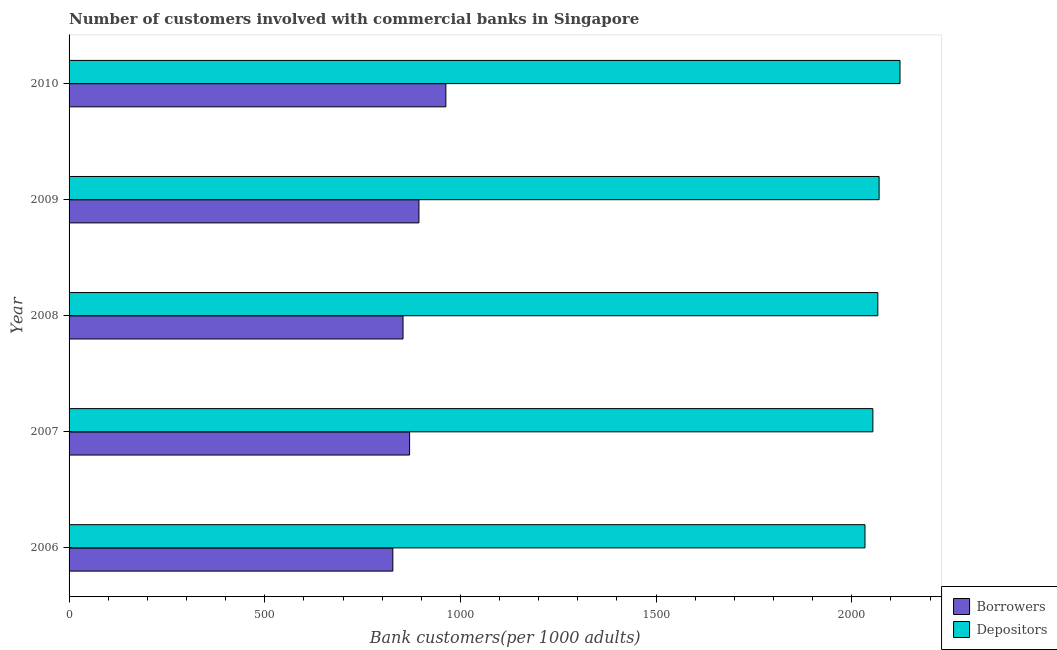How many different coloured bars are there?
Ensure brevity in your answer.  2. How many bars are there on the 3rd tick from the top?
Give a very brief answer. 2. What is the number of depositors in 2007?
Provide a succinct answer. 2053.95. Across all years, what is the maximum number of depositors?
Your answer should be compact. 2123.28. Across all years, what is the minimum number of depositors?
Provide a succinct answer. 2033.78. What is the total number of borrowers in the graph?
Ensure brevity in your answer.  4407.61. What is the difference between the number of borrowers in 2006 and that in 2010?
Offer a very short reply. -135.48. What is the difference between the number of borrowers in 2009 and the number of depositors in 2008?
Ensure brevity in your answer.  -1172.56. What is the average number of depositors per year?
Give a very brief answer. 2069.49. In the year 2007, what is the difference between the number of depositors and number of borrowers?
Give a very brief answer. 1183.82. What is the ratio of the number of depositors in 2007 to that in 2009?
Make the answer very short. 0.99. Is the number of depositors in 2008 less than that in 2010?
Ensure brevity in your answer.  Yes. Is the difference between the number of borrowers in 2008 and 2010 greater than the difference between the number of depositors in 2008 and 2010?
Provide a succinct answer. No. What is the difference between the highest and the second highest number of depositors?
Provide a succinct answer. 53.4. What is the difference between the highest and the lowest number of depositors?
Ensure brevity in your answer.  89.5. In how many years, is the number of depositors greater than the average number of depositors taken over all years?
Your answer should be very brief. 2. What does the 1st bar from the top in 2010 represents?
Provide a succinct answer. Depositors. What does the 1st bar from the bottom in 2009 represents?
Keep it short and to the point. Borrowers. How many bars are there?
Your answer should be compact. 10. Are all the bars in the graph horizontal?
Offer a terse response. Yes. How many years are there in the graph?
Provide a succinct answer. 5. Does the graph contain any zero values?
Ensure brevity in your answer.  No. Does the graph contain grids?
Offer a very short reply. No. How many legend labels are there?
Offer a terse response. 2. How are the legend labels stacked?
Your response must be concise. Vertical. What is the title of the graph?
Your response must be concise. Number of customers involved with commercial banks in Singapore. Does "Foreign Liabilities" appear as one of the legend labels in the graph?
Your answer should be compact. No. What is the label or title of the X-axis?
Your answer should be very brief. Bank customers(per 1000 adults). What is the Bank customers(per 1000 adults) in Borrowers in 2006?
Your answer should be compact. 827.32. What is the Bank customers(per 1000 adults) of Depositors in 2006?
Provide a succinct answer. 2033.78. What is the Bank customers(per 1000 adults) of Borrowers in 2007?
Make the answer very short. 870.13. What is the Bank customers(per 1000 adults) in Depositors in 2007?
Provide a short and direct response. 2053.95. What is the Bank customers(per 1000 adults) of Borrowers in 2008?
Your answer should be very brief. 853.36. What is the Bank customers(per 1000 adults) of Depositors in 2008?
Ensure brevity in your answer.  2066.57. What is the Bank customers(per 1000 adults) of Borrowers in 2009?
Your response must be concise. 894.01. What is the Bank customers(per 1000 adults) of Depositors in 2009?
Your answer should be very brief. 2069.88. What is the Bank customers(per 1000 adults) in Borrowers in 2010?
Ensure brevity in your answer.  962.8. What is the Bank customers(per 1000 adults) in Depositors in 2010?
Ensure brevity in your answer.  2123.28. Across all years, what is the maximum Bank customers(per 1000 adults) of Borrowers?
Your response must be concise. 962.8. Across all years, what is the maximum Bank customers(per 1000 adults) of Depositors?
Ensure brevity in your answer.  2123.28. Across all years, what is the minimum Bank customers(per 1000 adults) of Borrowers?
Offer a terse response. 827.32. Across all years, what is the minimum Bank customers(per 1000 adults) of Depositors?
Your response must be concise. 2033.78. What is the total Bank customers(per 1000 adults) of Borrowers in the graph?
Ensure brevity in your answer.  4407.61. What is the total Bank customers(per 1000 adults) in Depositors in the graph?
Make the answer very short. 1.03e+04. What is the difference between the Bank customers(per 1000 adults) of Borrowers in 2006 and that in 2007?
Provide a short and direct response. -42.81. What is the difference between the Bank customers(per 1000 adults) of Depositors in 2006 and that in 2007?
Offer a very short reply. -20.17. What is the difference between the Bank customers(per 1000 adults) in Borrowers in 2006 and that in 2008?
Keep it short and to the point. -26.04. What is the difference between the Bank customers(per 1000 adults) in Depositors in 2006 and that in 2008?
Provide a succinct answer. -32.79. What is the difference between the Bank customers(per 1000 adults) in Borrowers in 2006 and that in 2009?
Keep it short and to the point. -66.7. What is the difference between the Bank customers(per 1000 adults) in Depositors in 2006 and that in 2009?
Your answer should be very brief. -36.1. What is the difference between the Bank customers(per 1000 adults) of Borrowers in 2006 and that in 2010?
Keep it short and to the point. -135.48. What is the difference between the Bank customers(per 1000 adults) of Depositors in 2006 and that in 2010?
Your response must be concise. -89.5. What is the difference between the Bank customers(per 1000 adults) in Borrowers in 2007 and that in 2008?
Your response must be concise. 16.77. What is the difference between the Bank customers(per 1000 adults) in Depositors in 2007 and that in 2008?
Your answer should be very brief. -12.63. What is the difference between the Bank customers(per 1000 adults) of Borrowers in 2007 and that in 2009?
Make the answer very short. -23.89. What is the difference between the Bank customers(per 1000 adults) in Depositors in 2007 and that in 2009?
Offer a terse response. -15.93. What is the difference between the Bank customers(per 1000 adults) of Borrowers in 2007 and that in 2010?
Your answer should be very brief. -92.67. What is the difference between the Bank customers(per 1000 adults) in Depositors in 2007 and that in 2010?
Offer a very short reply. -69.33. What is the difference between the Bank customers(per 1000 adults) in Borrowers in 2008 and that in 2009?
Provide a succinct answer. -40.65. What is the difference between the Bank customers(per 1000 adults) of Depositors in 2008 and that in 2009?
Offer a very short reply. -3.3. What is the difference between the Bank customers(per 1000 adults) in Borrowers in 2008 and that in 2010?
Provide a short and direct response. -109.44. What is the difference between the Bank customers(per 1000 adults) in Depositors in 2008 and that in 2010?
Your answer should be very brief. -56.7. What is the difference between the Bank customers(per 1000 adults) in Borrowers in 2009 and that in 2010?
Your answer should be very brief. -68.78. What is the difference between the Bank customers(per 1000 adults) of Depositors in 2009 and that in 2010?
Give a very brief answer. -53.4. What is the difference between the Bank customers(per 1000 adults) of Borrowers in 2006 and the Bank customers(per 1000 adults) of Depositors in 2007?
Keep it short and to the point. -1226.63. What is the difference between the Bank customers(per 1000 adults) in Borrowers in 2006 and the Bank customers(per 1000 adults) in Depositors in 2008?
Your response must be concise. -1239.26. What is the difference between the Bank customers(per 1000 adults) in Borrowers in 2006 and the Bank customers(per 1000 adults) in Depositors in 2009?
Make the answer very short. -1242.56. What is the difference between the Bank customers(per 1000 adults) of Borrowers in 2006 and the Bank customers(per 1000 adults) of Depositors in 2010?
Provide a short and direct response. -1295.96. What is the difference between the Bank customers(per 1000 adults) of Borrowers in 2007 and the Bank customers(per 1000 adults) of Depositors in 2008?
Offer a terse response. -1196.45. What is the difference between the Bank customers(per 1000 adults) in Borrowers in 2007 and the Bank customers(per 1000 adults) in Depositors in 2009?
Your answer should be compact. -1199.75. What is the difference between the Bank customers(per 1000 adults) of Borrowers in 2007 and the Bank customers(per 1000 adults) of Depositors in 2010?
Your answer should be compact. -1253.15. What is the difference between the Bank customers(per 1000 adults) of Borrowers in 2008 and the Bank customers(per 1000 adults) of Depositors in 2009?
Your answer should be very brief. -1216.52. What is the difference between the Bank customers(per 1000 adults) of Borrowers in 2008 and the Bank customers(per 1000 adults) of Depositors in 2010?
Provide a succinct answer. -1269.92. What is the difference between the Bank customers(per 1000 adults) in Borrowers in 2009 and the Bank customers(per 1000 adults) in Depositors in 2010?
Keep it short and to the point. -1229.27. What is the average Bank customers(per 1000 adults) of Borrowers per year?
Keep it short and to the point. 881.52. What is the average Bank customers(per 1000 adults) in Depositors per year?
Offer a terse response. 2069.49. In the year 2006, what is the difference between the Bank customers(per 1000 adults) in Borrowers and Bank customers(per 1000 adults) in Depositors?
Provide a short and direct response. -1206.46. In the year 2007, what is the difference between the Bank customers(per 1000 adults) of Borrowers and Bank customers(per 1000 adults) of Depositors?
Your response must be concise. -1183.82. In the year 2008, what is the difference between the Bank customers(per 1000 adults) in Borrowers and Bank customers(per 1000 adults) in Depositors?
Keep it short and to the point. -1213.21. In the year 2009, what is the difference between the Bank customers(per 1000 adults) in Borrowers and Bank customers(per 1000 adults) in Depositors?
Keep it short and to the point. -1175.87. In the year 2010, what is the difference between the Bank customers(per 1000 adults) of Borrowers and Bank customers(per 1000 adults) of Depositors?
Your answer should be compact. -1160.48. What is the ratio of the Bank customers(per 1000 adults) in Borrowers in 2006 to that in 2007?
Your answer should be very brief. 0.95. What is the ratio of the Bank customers(per 1000 adults) in Depositors in 2006 to that in 2007?
Offer a terse response. 0.99. What is the ratio of the Bank customers(per 1000 adults) in Borrowers in 2006 to that in 2008?
Provide a succinct answer. 0.97. What is the ratio of the Bank customers(per 1000 adults) of Depositors in 2006 to that in 2008?
Provide a short and direct response. 0.98. What is the ratio of the Bank customers(per 1000 adults) of Borrowers in 2006 to that in 2009?
Make the answer very short. 0.93. What is the ratio of the Bank customers(per 1000 adults) of Depositors in 2006 to that in 2009?
Your answer should be very brief. 0.98. What is the ratio of the Bank customers(per 1000 adults) of Borrowers in 2006 to that in 2010?
Make the answer very short. 0.86. What is the ratio of the Bank customers(per 1000 adults) in Depositors in 2006 to that in 2010?
Keep it short and to the point. 0.96. What is the ratio of the Bank customers(per 1000 adults) of Borrowers in 2007 to that in 2008?
Give a very brief answer. 1.02. What is the ratio of the Bank customers(per 1000 adults) in Borrowers in 2007 to that in 2009?
Your response must be concise. 0.97. What is the ratio of the Bank customers(per 1000 adults) in Borrowers in 2007 to that in 2010?
Keep it short and to the point. 0.9. What is the ratio of the Bank customers(per 1000 adults) of Depositors in 2007 to that in 2010?
Your response must be concise. 0.97. What is the ratio of the Bank customers(per 1000 adults) of Borrowers in 2008 to that in 2009?
Make the answer very short. 0.95. What is the ratio of the Bank customers(per 1000 adults) in Borrowers in 2008 to that in 2010?
Ensure brevity in your answer.  0.89. What is the ratio of the Bank customers(per 1000 adults) of Depositors in 2008 to that in 2010?
Offer a terse response. 0.97. What is the ratio of the Bank customers(per 1000 adults) in Borrowers in 2009 to that in 2010?
Provide a succinct answer. 0.93. What is the ratio of the Bank customers(per 1000 adults) in Depositors in 2009 to that in 2010?
Your response must be concise. 0.97. What is the difference between the highest and the second highest Bank customers(per 1000 adults) in Borrowers?
Offer a terse response. 68.78. What is the difference between the highest and the second highest Bank customers(per 1000 adults) in Depositors?
Your answer should be compact. 53.4. What is the difference between the highest and the lowest Bank customers(per 1000 adults) in Borrowers?
Make the answer very short. 135.48. What is the difference between the highest and the lowest Bank customers(per 1000 adults) of Depositors?
Provide a succinct answer. 89.5. 